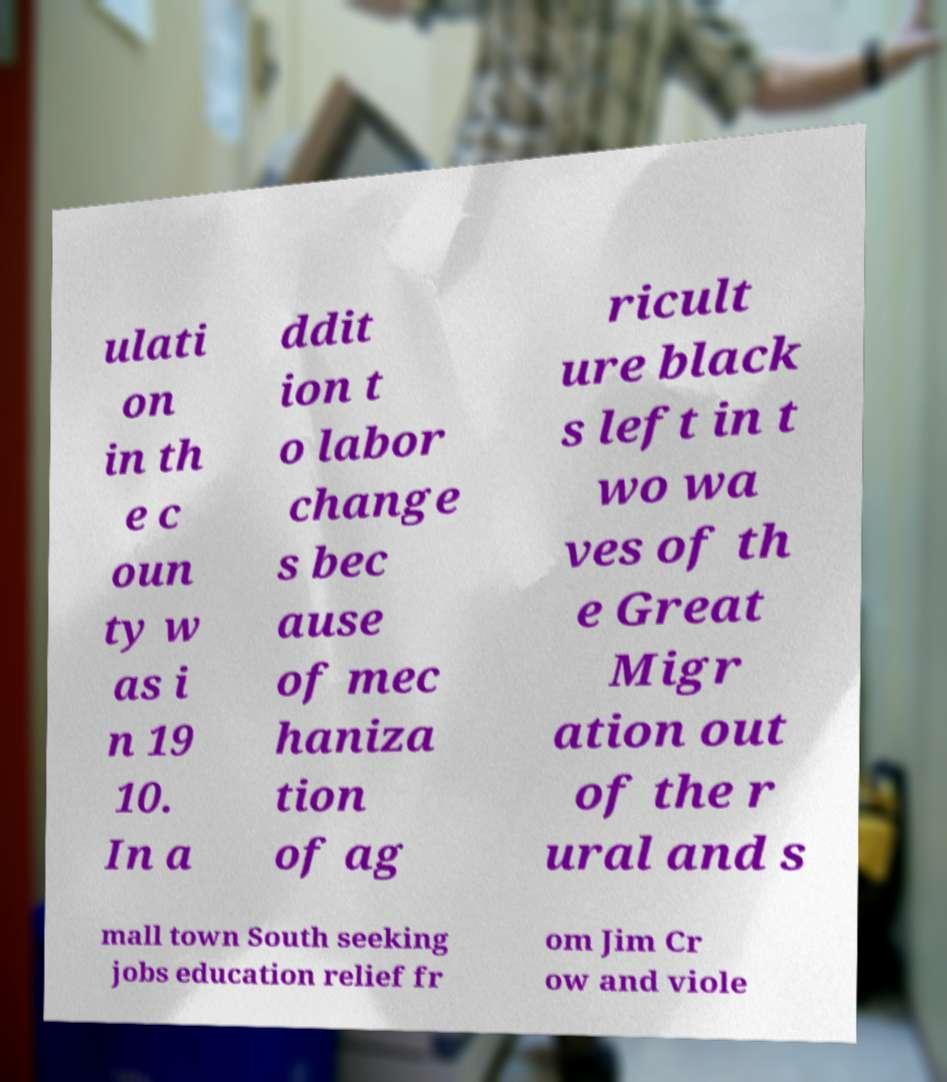Could you extract and type out the text from this image? ulati on in th e c oun ty w as i n 19 10. In a ddit ion t o labor change s bec ause of mec haniza tion of ag ricult ure black s left in t wo wa ves of th e Great Migr ation out of the r ural and s mall town South seeking jobs education relief fr om Jim Cr ow and viole 